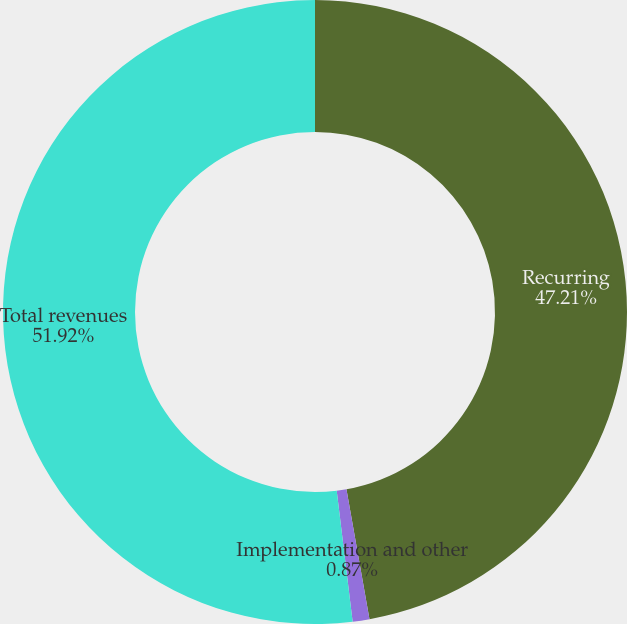Convert chart to OTSL. <chart><loc_0><loc_0><loc_500><loc_500><pie_chart><fcel>Recurring<fcel>Implementation and other<fcel>Total revenues<nl><fcel>47.21%<fcel>0.87%<fcel>51.93%<nl></chart> 